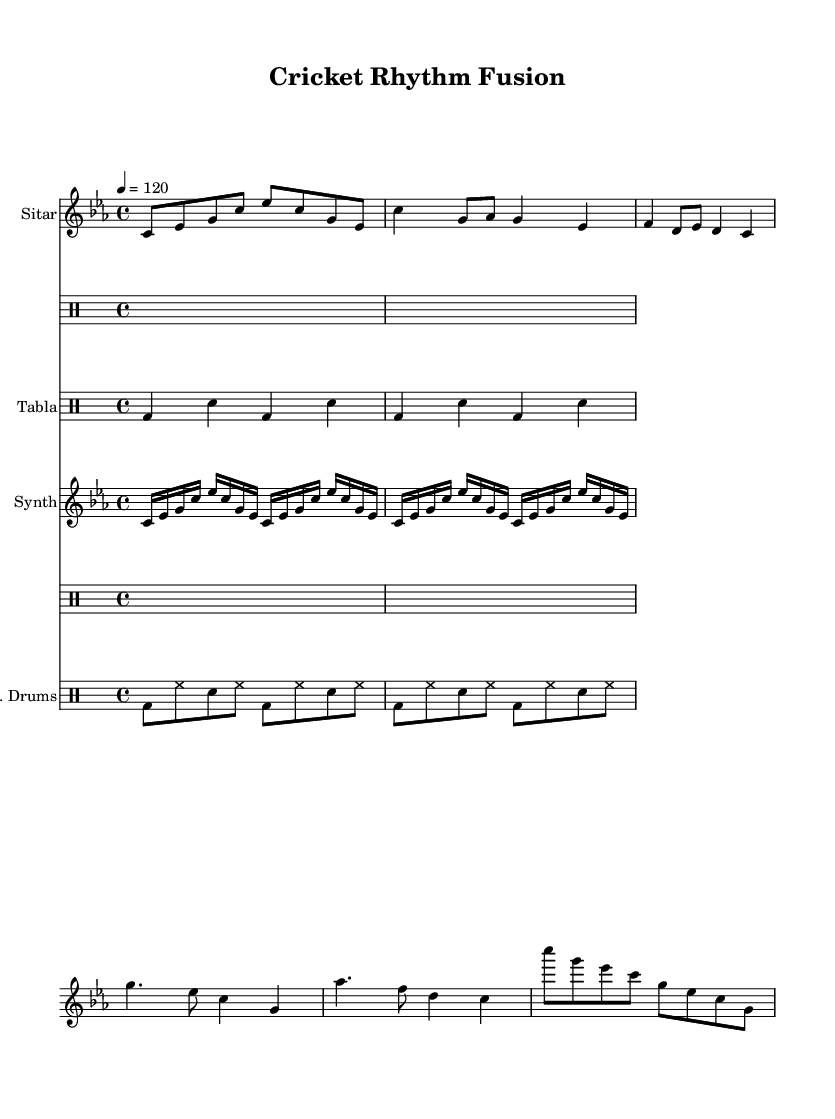What is the key signature of this music? The key signature is C minor, which has three flats (B flat, E flat, and A flat). This can be confirmed by looking for the key signature symbol at the beginning of the sheet music.
Answer: C minor What is the time signature of the piece? The time signature is 4/4, indicated by the numbers displayed at the beginning of the score. This means there are four beats in each measure, and a quarter note gets one beat.
Answer: 4/4 What is the tempo marking of the music? The tempo marking is 120 BPM (beats per minute), indicated by the tempo text above the staff. This tells the performer to play at a moderate speed.
Answer: 120 How many instruments are featured in this piece? There are four different instrument parts indicated in the score: Sitar, Tabla, Synthesizer, and Electronic Drums. Each is shown with its respective staff.
Answer: Four What type of rhythmic pattern is used in the Tabla section? The Tabla section features a basic pattern that alternates between bass (bd) and snare (sn) hits, creating a repetitive and driving rhythm characteristic of traditional Indian music. This can be identified by reading the rhythmic notations in the drum staff.
Answer: Repetitive basic pattern What forms the main elements of the Chorus? The Chorus includes two primary phrases which consist of a combination of pitches (g, es, c, as, f) played in a rhythmic structure. Analyzing the notes and their arrangements identifies this section.
Answer: g, es, c, as, f How does the Synthesizer part contribute to the music's texture? The Synthesizer contributes an arpeggiated pattern played in sixteenth notes, which adds a layer of harmony and richness to the overall sound. This can be determined by analyzing the rapid note sequences in this section.
Answer: Arpeggiated pattern 